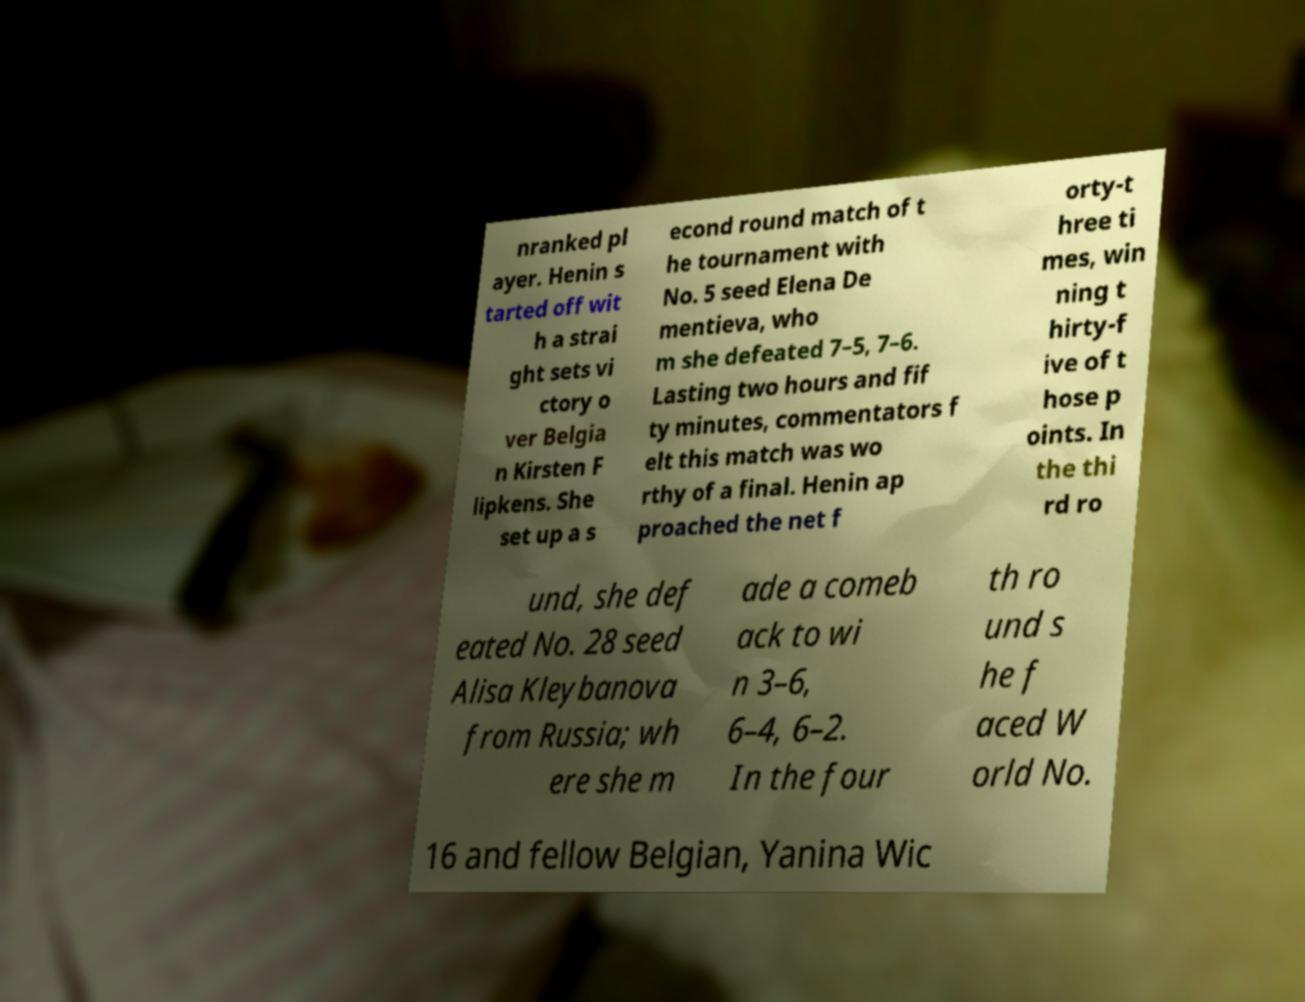Can you accurately transcribe the text from the provided image for me? nranked pl ayer. Henin s tarted off wit h a strai ght sets vi ctory o ver Belgia n Kirsten F lipkens. She set up a s econd round match of t he tournament with No. 5 seed Elena De mentieva, who m she defeated 7–5, 7–6. Lasting two hours and fif ty minutes, commentators f elt this match was wo rthy of a final. Henin ap proached the net f orty-t hree ti mes, win ning t hirty-f ive of t hose p oints. In the thi rd ro und, she def eated No. 28 seed Alisa Kleybanova from Russia; wh ere she m ade a comeb ack to wi n 3–6, 6–4, 6–2. In the four th ro und s he f aced W orld No. 16 and fellow Belgian, Yanina Wic 